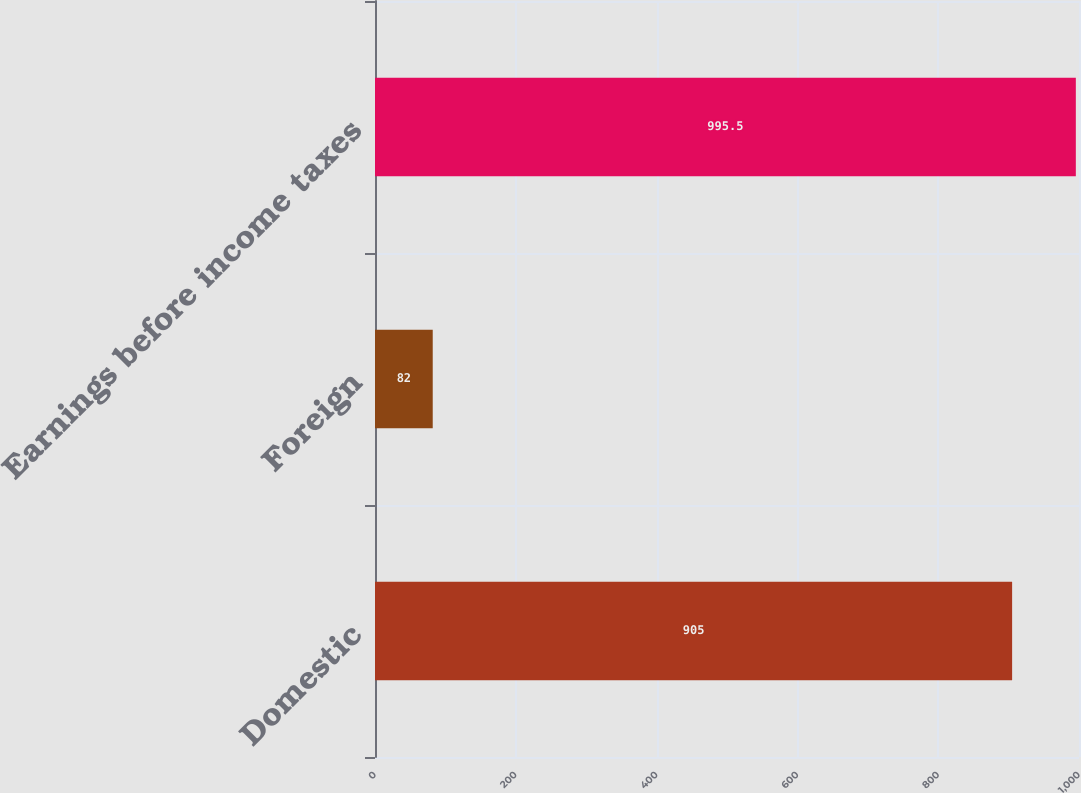<chart> <loc_0><loc_0><loc_500><loc_500><bar_chart><fcel>Domestic<fcel>Foreign<fcel>Earnings before income taxes<nl><fcel>905<fcel>82<fcel>995.5<nl></chart> 